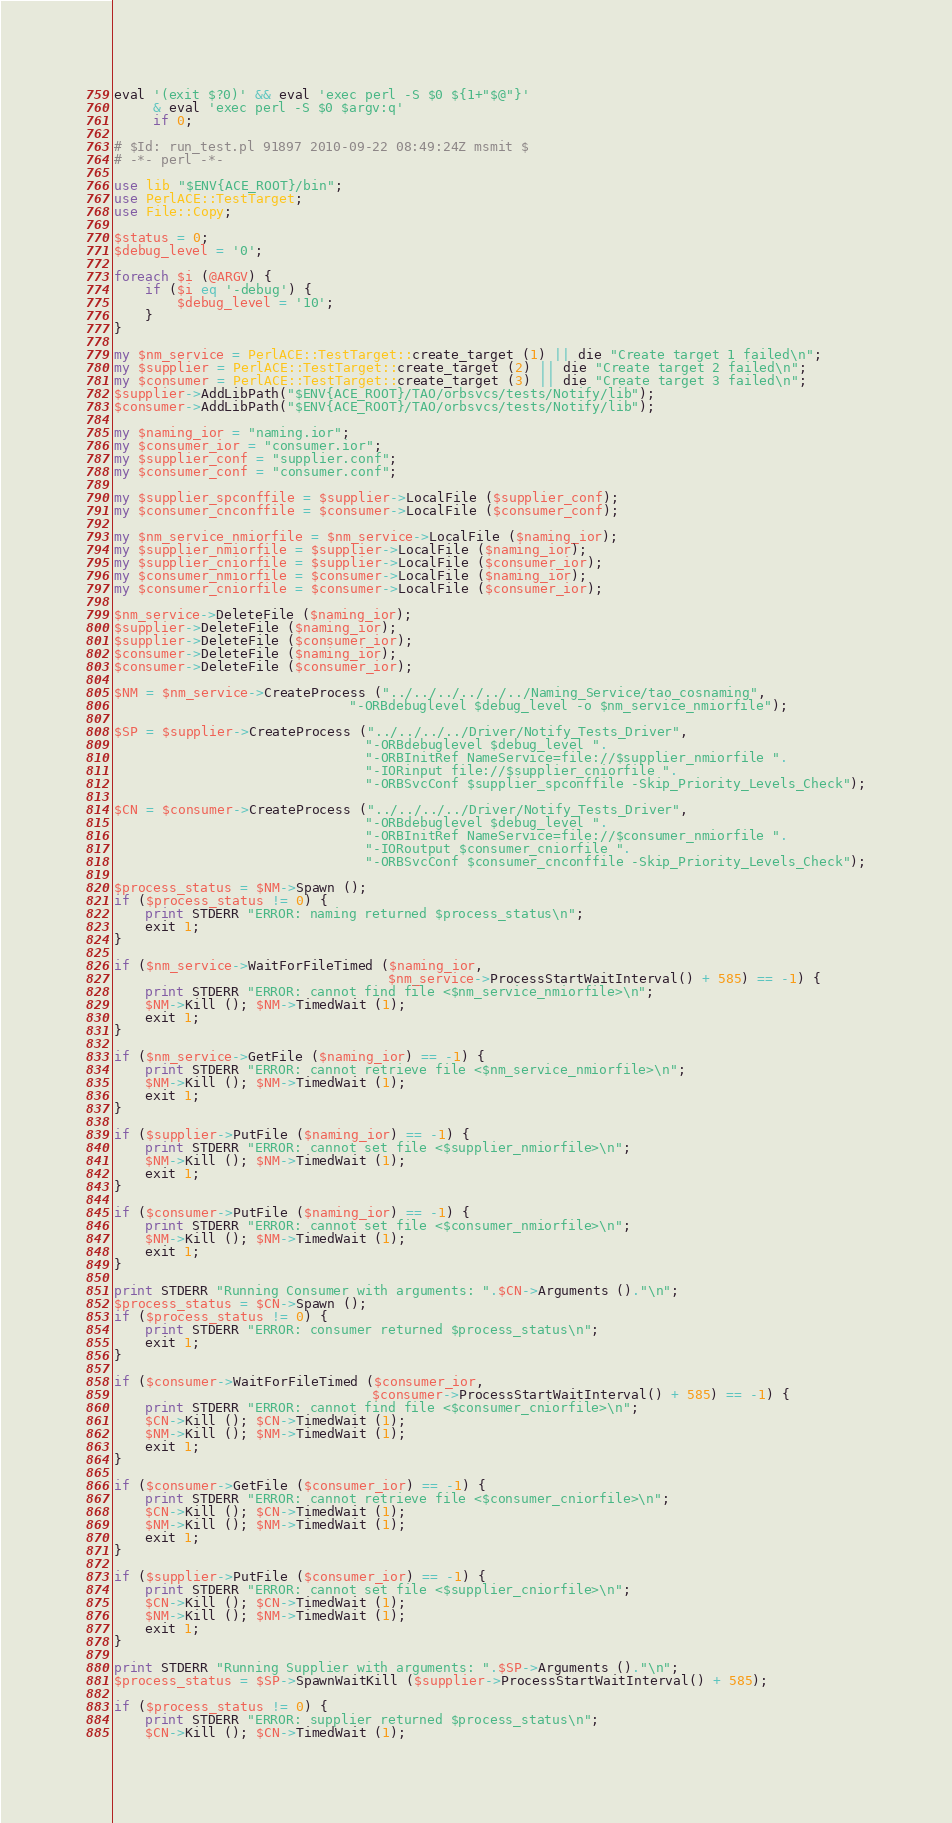Convert code to text. <code><loc_0><loc_0><loc_500><loc_500><_Perl_>eval '(exit $?0)' && eval 'exec perl -S $0 ${1+"$@"}'
     & eval 'exec perl -S $0 $argv:q'
     if 0;

# $Id: run_test.pl 91897 2010-09-22 08:49:24Z msmit $
# -*- perl -*-

use lib "$ENV{ACE_ROOT}/bin";
use PerlACE::TestTarget;
use File::Copy;

$status = 0;
$debug_level = '0';

foreach $i (@ARGV) {
    if ($i eq '-debug') {
        $debug_level = '10';
    }
}

my $nm_service = PerlACE::TestTarget::create_target (1) || die "Create target 1 failed\n";
my $supplier = PerlACE::TestTarget::create_target (2) || die "Create target 2 failed\n";
my $consumer = PerlACE::TestTarget::create_target (3) || die "Create target 3 failed\n";
$supplier->AddLibPath("$ENV{ACE_ROOT}/TAO/orbsvcs/tests/Notify/lib");
$consumer->AddLibPath("$ENV{ACE_ROOT}/TAO/orbsvcs/tests/Notify/lib");

my $naming_ior = "naming.ior";
my $consumer_ior = "consumer.ior";
my $supplier_conf = "supplier.conf";
my $consumer_conf = "consumer.conf";

my $supplier_spconffile = $supplier->LocalFile ($supplier_conf);
my $consumer_cnconffile = $consumer->LocalFile ($consumer_conf);

my $nm_service_nmiorfile = $nm_service->LocalFile ($naming_ior);
my $supplier_nmiorfile = $supplier->LocalFile ($naming_ior);
my $supplier_cniorfile = $supplier->LocalFile ($consumer_ior);
my $consumer_nmiorfile = $consumer->LocalFile ($naming_ior);
my $consumer_cniorfile = $consumer->LocalFile ($consumer_ior);

$nm_service->DeleteFile ($naming_ior);
$supplier->DeleteFile ($naming_ior);
$supplier->DeleteFile ($consumer_ior);
$consumer->DeleteFile ($naming_ior);
$consumer->DeleteFile ($consumer_ior);

$NM = $nm_service->CreateProcess ("../../../../../../Naming_Service/tao_cosnaming",
                              "-ORBdebuglevel $debug_level -o $nm_service_nmiorfile");

$SP = $supplier->CreateProcess ("../../../../Driver/Notify_Tests_Driver",
                                "-ORBdebuglevel $debug_level ".
                                "-ORBInitRef NameService=file://$supplier_nmiorfile ".
                                "-IORinput file://$supplier_cniorfile ".
                                "-ORBSvcConf $supplier_spconffile -Skip_Priority_Levels_Check");

$CN = $consumer->CreateProcess ("../../../../Driver/Notify_Tests_Driver",
                                "-ORBdebuglevel $debug_level ".
                                "-ORBInitRef NameService=file://$consumer_nmiorfile ".
                                "-IORoutput $consumer_cniorfile ".
                                "-ORBSvcConf $consumer_cnconffile -Skip_Priority_Levels_Check");

$process_status = $NM->Spawn ();
if ($process_status != 0) {
    print STDERR "ERROR: naming returned $process_status\n";
    exit 1;
}

if ($nm_service->WaitForFileTimed ($naming_ior,
                                   $nm_service->ProcessStartWaitInterval() + 585) == -1) {
    print STDERR "ERROR: cannot find file <$nm_service_nmiorfile>\n";
    $NM->Kill (); $NM->TimedWait (1);
    exit 1;
}

if ($nm_service->GetFile ($naming_ior) == -1) {
    print STDERR "ERROR: cannot retrieve file <$nm_service_nmiorfile>\n";
    $NM->Kill (); $NM->TimedWait (1);
    exit 1;
}

if ($supplier->PutFile ($naming_ior) == -1) {
    print STDERR "ERROR: cannot set file <$supplier_nmiorfile>\n";
    $NM->Kill (); $NM->TimedWait (1);
    exit 1;
}

if ($consumer->PutFile ($naming_ior) == -1) {
    print STDERR "ERROR: cannot set file <$consumer_nmiorfile>\n";
    $NM->Kill (); $NM->TimedWait (1);
    exit 1;
}

print STDERR "Running Consumer with arguments: ".$CN->Arguments ()."\n";
$process_status = $CN->Spawn ();
if ($process_status != 0) {
    print STDERR "ERROR: consumer returned $process_status\n";
    exit 1;
}

if ($consumer->WaitForFileTimed ($consumer_ior,
                                 $consumer->ProcessStartWaitInterval() + 585) == -1) {
    print STDERR "ERROR: cannot find file <$consumer_cniorfile>\n";
    $CN->Kill (); $CN->TimedWait (1);
    $NM->Kill (); $NM->TimedWait (1);
    exit 1;
}

if ($consumer->GetFile ($consumer_ior) == -1) {
    print STDERR "ERROR: cannot retrieve file <$consumer_cniorfile>\n";
    $CN->Kill (); $CN->TimedWait (1);
    $NM->Kill (); $NM->TimedWait (1);
    exit 1;
}

if ($supplier->PutFile ($consumer_ior) == -1) {
    print STDERR "ERROR: cannot set file <$supplier_cniorfile>\n";
    $CN->Kill (); $CN->TimedWait (1);
    $NM->Kill (); $NM->TimedWait (1);
    exit 1;
}

print STDERR "Running Supplier with arguments: ".$SP->Arguments ()."\n";
$process_status = $SP->SpawnWaitKill ($supplier->ProcessStartWaitInterval() + 585);

if ($process_status != 0) {
    print STDERR "ERROR: supplier returned $process_status\n";
    $CN->Kill (); $CN->TimedWait (1);</code> 